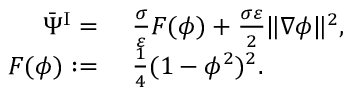Convert formula to latex. <formula><loc_0><loc_0><loc_500><loc_500>\begin{array} { r l } { \bar { \Psi } ^ { I } = } & \frac { \sigma } { \varepsilon } F ( \phi ) + \frac { \sigma \varepsilon } { 2 } \| \nabla \phi \| ^ { 2 } , } \\ { F ( \phi ) \colon = } & \frac { 1 } { 4 } ( 1 - \phi ^ { 2 } ) ^ { 2 } . } \end{array}</formula> 